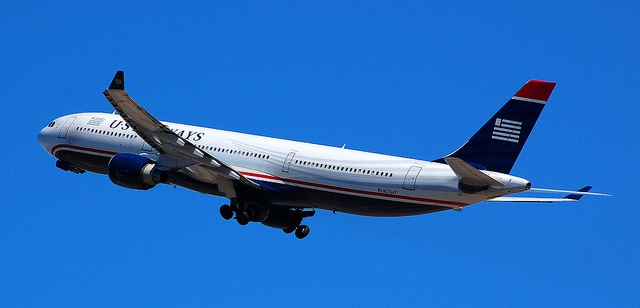Describe the objects in this image and their specific colors. I can see a airplane in blue, black, white, and gray tones in this image. 